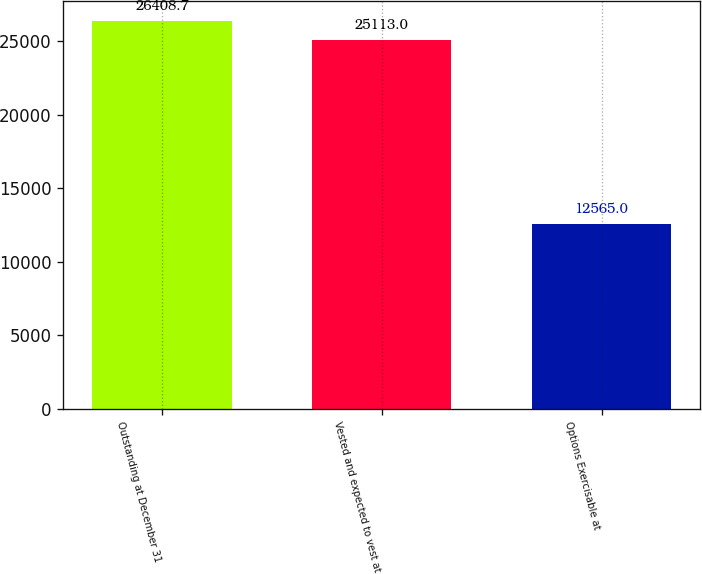Convert chart to OTSL. <chart><loc_0><loc_0><loc_500><loc_500><bar_chart><fcel>Outstanding at December 31<fcel>Vested and expected to vest at<fcel>Options Exercisable at<nl><fcel>26408.7<fcel>25113<fcel>12565<nl></chart> 